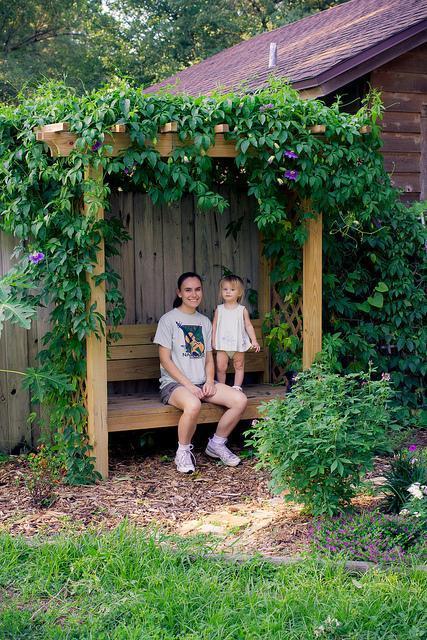How many people are in the picture?
Give a very brief answer. 2. How many people are visible?
Give a very brief answer. 2. 